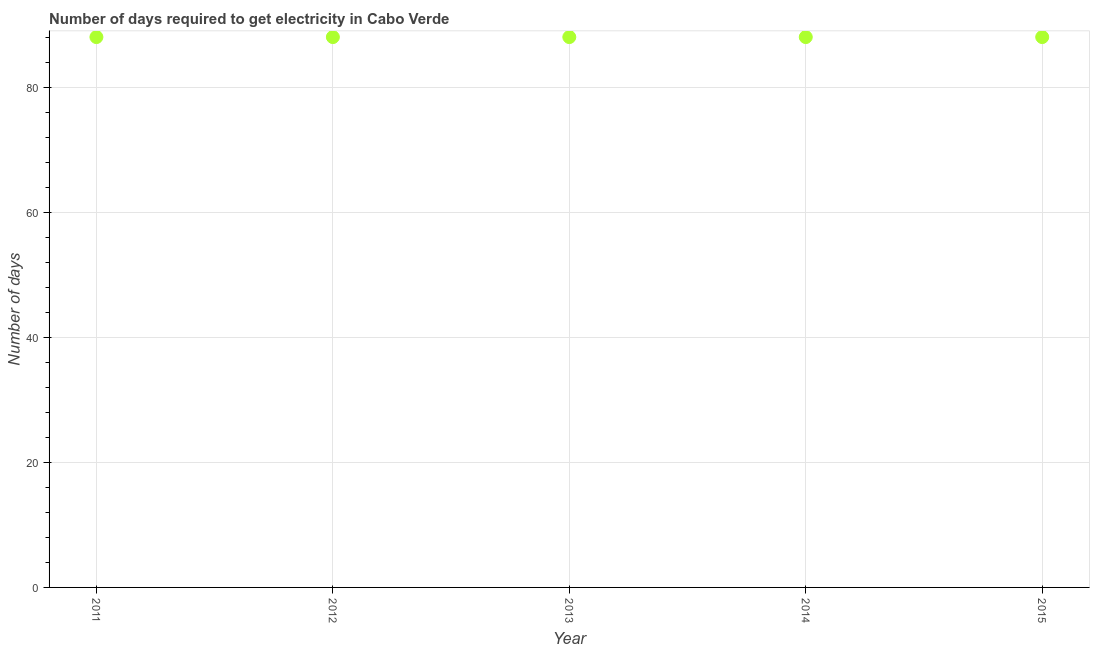What is the time to get electricity in 2014?
Provide a short and direct response. 88. Across all years, what is the maximum time to get electricity?
Your answer should be compact. 88. Across all years, what is the minimum time to get electricity?
Your answer should be compact. 88. In which year was the time to get electricity minimum?
Give a very brief answer. 2011. What is the sum of the time to get electricity?
Offer a very short reply. 440. What is the difference between the time to get electricity in 2012 and 2015?
Give a very brief answer. 0. What is the average time to get electricity per year?
Offer a very short reply. 88. What is the median time to get electricity?
Keep it short and to the point. 88. Is the time to get electricity in 2012 less than that in 2015?
Provide a short and direct response. No. Is the difference between the time to get electricity in 2012 and 2015 greater than the difference between any two years?
Give a very brief answer. Yes. What is the difference between the highest and the second highest time to get electricity?
Your response must be concise. 0. Is the sum of the time to get electricity in 2012 and 2015 greater than the maximum time to get electricity across all years?
Provide a short and direct response. Yes. What is the difference between the highest and the lowest time to get electricity?
Provide a succinct answer. 0. Does the time to get electricity monotonically increase over the years?
Ensure brevity in your answer.  No. What is the difference between two consecutive major ticks on the Y-axis?
Offer a very short reply. 20. Are the values on the major ticks of Y-axis written in scientific E-notation?
Make the answer very short. No. Does the graph contain any zero values?
Keep it short and to the point. No. What is the title of the graph?
Give a very brief answer. Number of days required to get electricity in Cabo Verde. What is the label or title of the Y-axis?
Your response must be concise. Number of days. What is the Number of days in 2011?
Provide a succinct answer. 88. What is the Number of days in 2012?
Your answer should be very brief. 88. What is the Number of days in 2013?
Offer a terse response. 88. What is the Number of days in 2014?
Your response must be concise. 88. What is the Number of days in 2015?
Offer a terse response. 88. What is the difference between the Number of days in 2011 and 2013?
Your answer should be compact. 0. What is the difference between the Number of days in 2011 and 2014?
Provide a succinct answer. 0. What is the difference between the Number of days in 2011 and 2015?
Provide a succinct answer. 0. What is the difference between the Number of days in 2012 and 2014?
Ensure brevity in your answer.  0. What is the difference between the Number of days in 2012 and 2015?
Your answer should be compact. 0. What is the difference between the Number of days in 2013 and 2014?
Give a very brief answer. 0. What is the difference between the Number of days in 2014 and 2015?
Your answer should be compact. 0. What is the ratio of the Number of days in 2011 to that in 2013?
Offer a terse response. 1. What is the ratio of the Number of days in 2011 to that in 2014?
Your answer should be compact. 1. What is the ratio of the Number of days in 2011 to that in 2015?
Ensure brevity in your answer.  1. What is the ratio of the Number of days in 2012 to that in 2013?
Ensure brevity in your answer.  1. What is the ratio of the Number of days in 2012 to that in 2015?
Your answer should be very brief. 1. What is the ratio of the Number of days in 2013 to that in 2014?
Your answer should be compact. 1. 